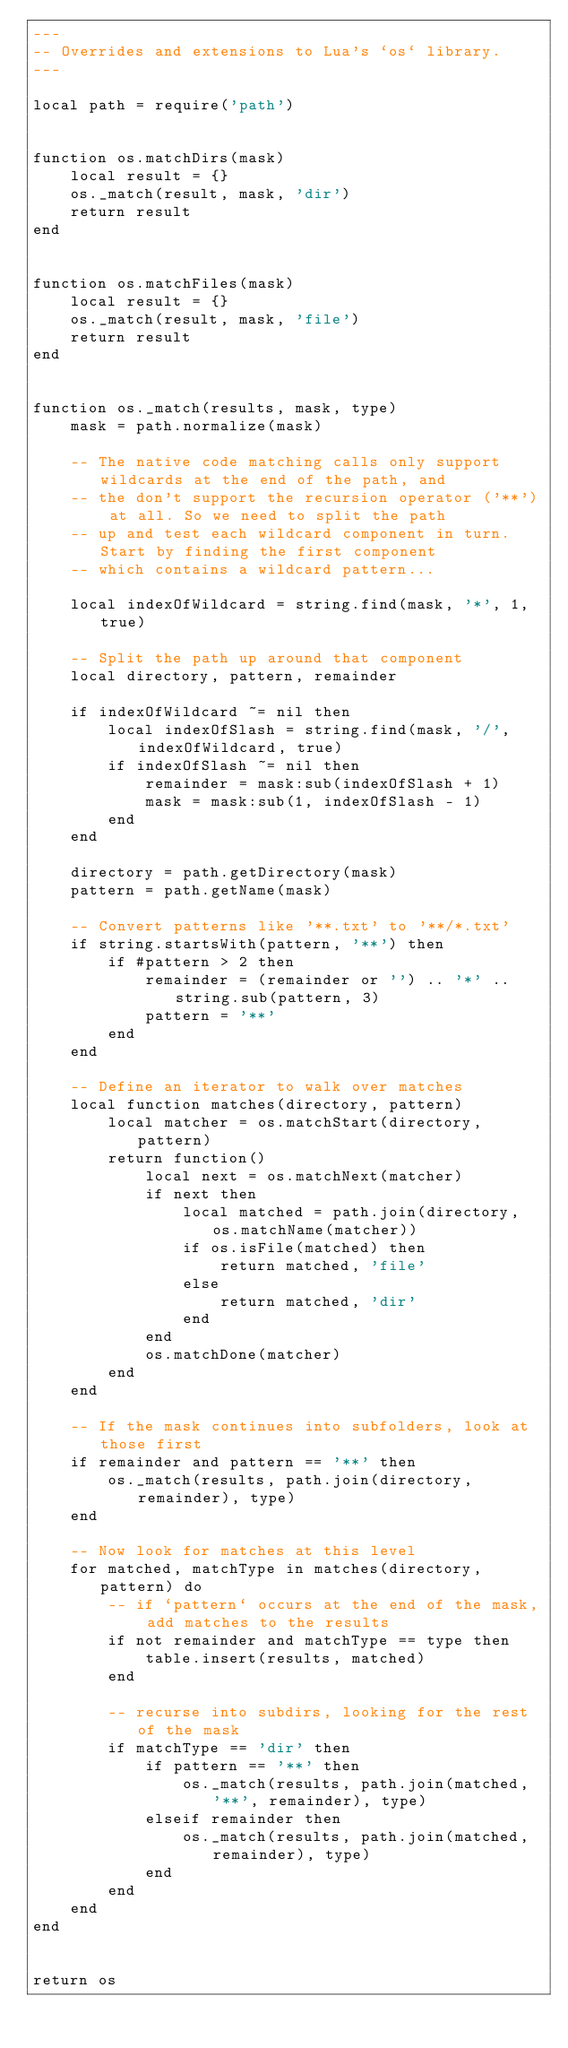Convert code to text. <code><loc_0><loc_0><loc_500><loc_500><_Lua_>---
-- Overrides and extensions to Lua's `os` library.
---

local path = require('path')


function os.matchDirs(mask)
	local result = {}
	os._match(result, mask, 'dir')
	return result
end


function os.matchFiles(mask)
	local result = {}
	os._match(result, mask, 'file')
	return result
end


function os._match(results, mask, type)
	mask = path.normalize(mask)

	-- The native code matching calls only support wildcards at the end of the path, and
	-- the don't support the recursion operator ('**') at all. So we need to split the path
	-- up and test each wildcard component in turn. Start by finding the first component
	-- which contains a wildcard pattern...

	local indexOfWildcard = string.find(mask, '*', 1, true)

	-- Split the path up around that component
	local directory, pattern, remainder

	if indexOfWildcard ~= nil then
		local indexOfSlash = string.find(mask, '/', indexOfWildcard, true)
		if indexOfSlash ~= nil then
			remainder = mask:sub(indexOfSlash + 1)
			mask = mask:sub(1, indexOfSlash - 1)
		end
	end

	directory = path.getDirectory(mask)
	pattern = path.getName(mask)

	-- Convert patterns like '**.txt' to '**/*.txt'
	if string.startsWith(pattern, '**') then
		if #pattern > 2 then
			remainder = (remainder or '') .. '*' .. string.sub(pattern, 3)
			pattern = '**'
		end
	end

	-- Define an iterator to walk over matches
	local function matches(directory, pattern)
		local matcher = os.matchStart(directory, pattern)
		return function()
			local next = os.matchNext(matcher)
			if next then
				local matched = path.join(directory, os.matchName(matcher))
				if os.isFile(matched) then
					return matched, 'file'
				else
					return matched, 'dir'
				end
			end
			os.matchDone(matcher)
		end
	end

	-- If the mask continues into subfolders, look at those first
	if remainder and pattern == '**' then
		os._match(results, path.join(directory, remainder), type)
	end

	-- Now look for matches at this level
	for matched, matchType in matches(directory, pattern) do
		-- if `pattern` occurs at the end of the mask, add matches to the results
		if not remainder and matchType == type then
			table.insert(results, matched)
		end

		-- recurse into subdirs, looking for the rest of the mask
		if matchType == 'dir' then
			if pattern == '**' then
				os._match(results, path.join(matched, '**', remainder), type)
			elseif remainder then
				os._match(results, path.join(matched, remainder), type)
			end
		end
	end
end


return os
</code> 